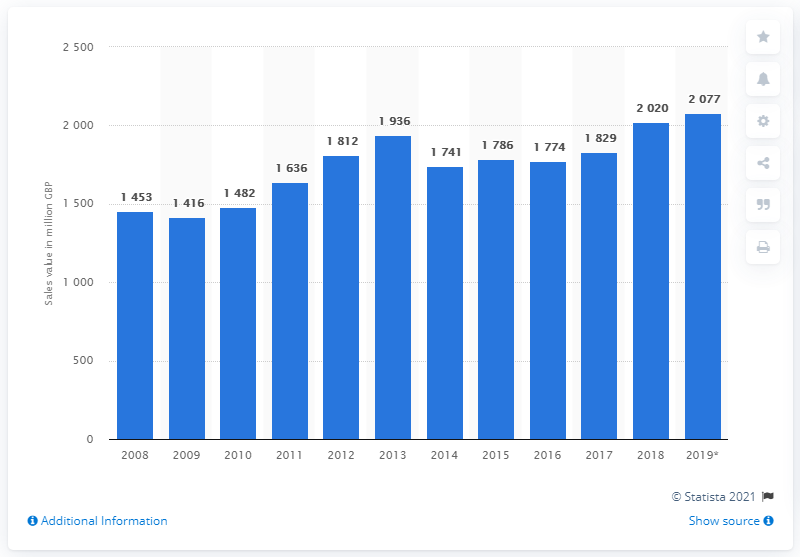Identify some key points in this picture. In the year 2008, the total sales value of condiments and seasonings in the UK began. 